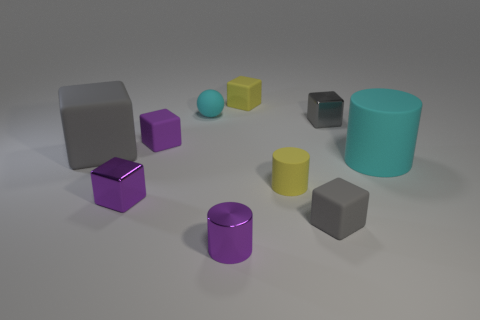What number of things are cyan cylinders or gray rubber objects?
Offer a terse response. 3. There is a small sphere that is behind the purple cube that is behind the metal cube that is on the left side of the metallic cylinder; what is it made of?
Make the answer very short. Rubber. What is the tiny gray block behind the small gray matte block made of?
Provide a succinct answer. Metal. Is there a cyan ball of the same size as the yellow rubber cylinder?
Ensure brevity in your answer.  Yes. Is the color of the large matte thing left of the cyan ball the same as the shiny cylinder?
Provide a short and direct response. No. How many cyan things are either large metallic cubes or matte objects?
Your response must be concise. 2. What number of small rubber blocks have the same color as the matte sphere?
Make the answer very short. 0. Does the yellow cube have the same material as the large cyan thing?
Keep it short and to the point. Yes. How many rubber blocks are in front of the shiny thing that is right of the purple metallic cylinder?
Provide a short and direct response. 3. Do the cyan cylinder and the yellow rubber cylinder have the same size?
Provide a succinct answer. No. 